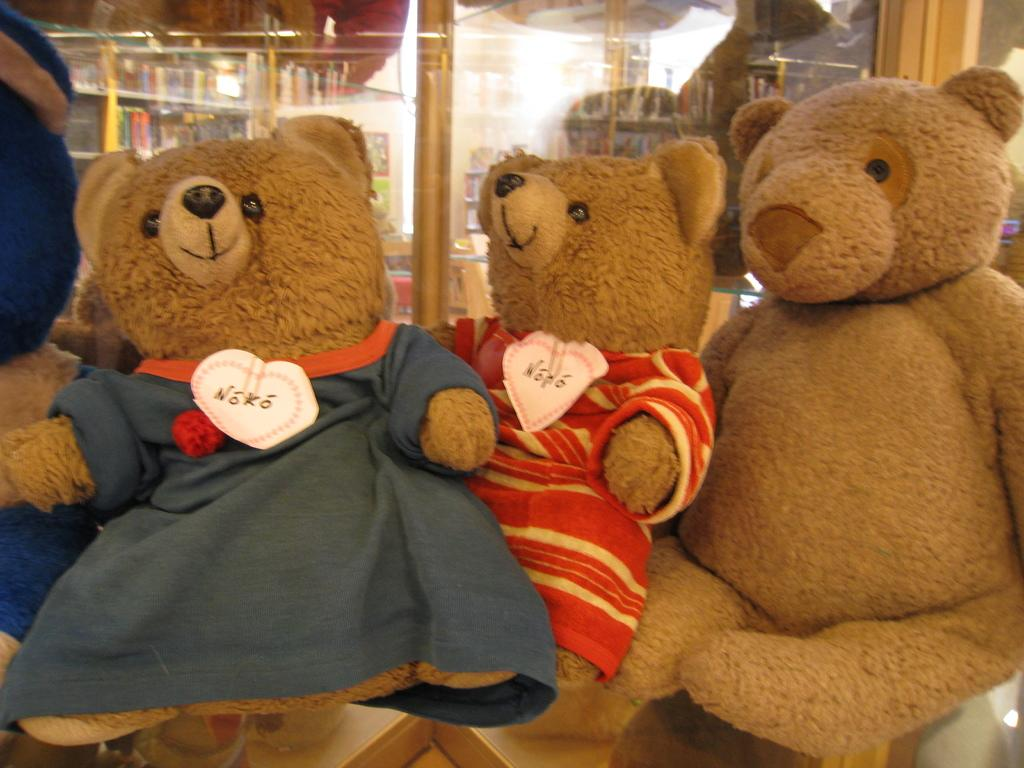What type of toys are in the image? There are teddy bears in the image. What material might the glass in the background of the image be made of? The glass in the background of the image might be made of glass. What type of teeth can be seen in the image? There are no teeth present in the image. What type of glue is being used to hold the teddy bears together in the image? There is no glue present in the image, and the teddy bears are not being held together. 